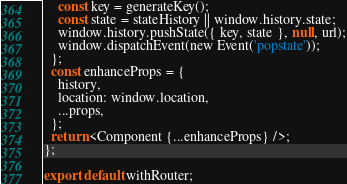<code> <loc_0><loc_0><loc_500><loc_500><_JavaScript_>    const key = generateKey();
    const state = stateHistory || window.history.state;
    window.history.pushState({ key, state }, null, url);
    window.dispatchEvent(new Event('popstate'));
  };
  const enhanceProps = {
    history,
    location: window.location,
    ...props,
  };
  return <Component {...enhanceProps} />;
};

export default withRouter;
</code> 